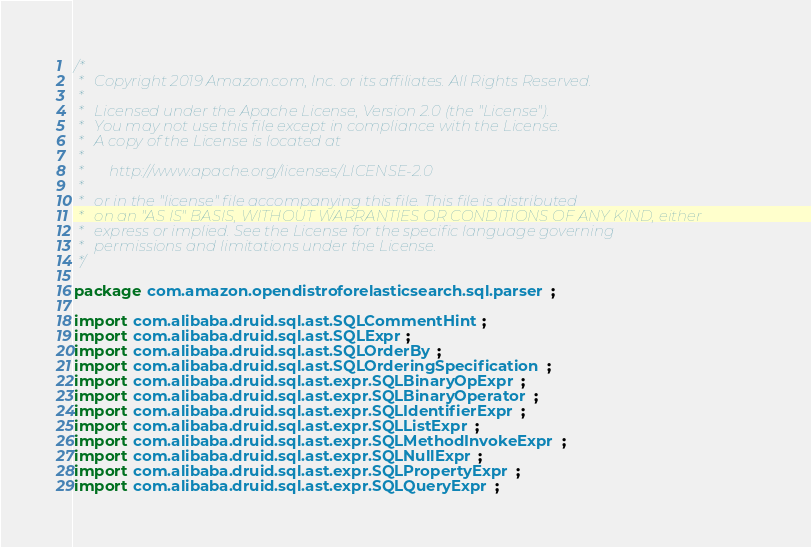Convert code to text. <code><loc_0><loc_0><loc_500><loc_500><_Java_>/*
 *   Copyright 2019 Amazon.com, Inc. or its affiliates. All Rights Reserved.
 *
 *   Licensed under the Apache License, Version 2.0 (the "License").
 *   You may not use this file except in compliance with the License.
 *   A copy of the License is located at
 *
 *       http://www.apache.org/licenses/LICENSE-2.0
 *
 *   or in the "license" file accompanying this file. This file is distributed
 *   on an "AS IS" BASIS, WITHOUT WARRANTIES OR CONDITIONS OF ANY KIND, either
 *   express or implied. See the License for the specific language governing
 *   permissions and limitations under the License.
 */

package com.amazon.opendistroforelasticsearch.sql.parser;

import com.alibaba.druid.sql.ast.SQLCommentHint;
import com.alibaba.druid.sql.ast.SQLExpr;
import com.alibaba.druid.sql.ast.SQLOrderBy;
import com.alibaba.druid.sql.ast.SQLOrderingSpecification;
import com.alibaba.druid.sql.ast.expr.SQLBinaryOpExpr;
import com.alibaba.druid.sql.ast.expr.SQLBinaryOperator;
import com.alibaba.druid.sql.ast.expr.SQLIdentifierExpr;
import com.alibaba.druid.sql.ast.expr.SQLListExpr;
import com.alibaba.druid.sql.ast.expr.SQLMethodInvokeExpr;
import com.alibaba.druid.sql.ast.expr.SQLNullExpr;
import com.alibaba.druid.sql.ast.expr.SQLPropertyExpr;
import com.alibaba.druid.sql.ast.expr.SQLQueryExpr;</code> 